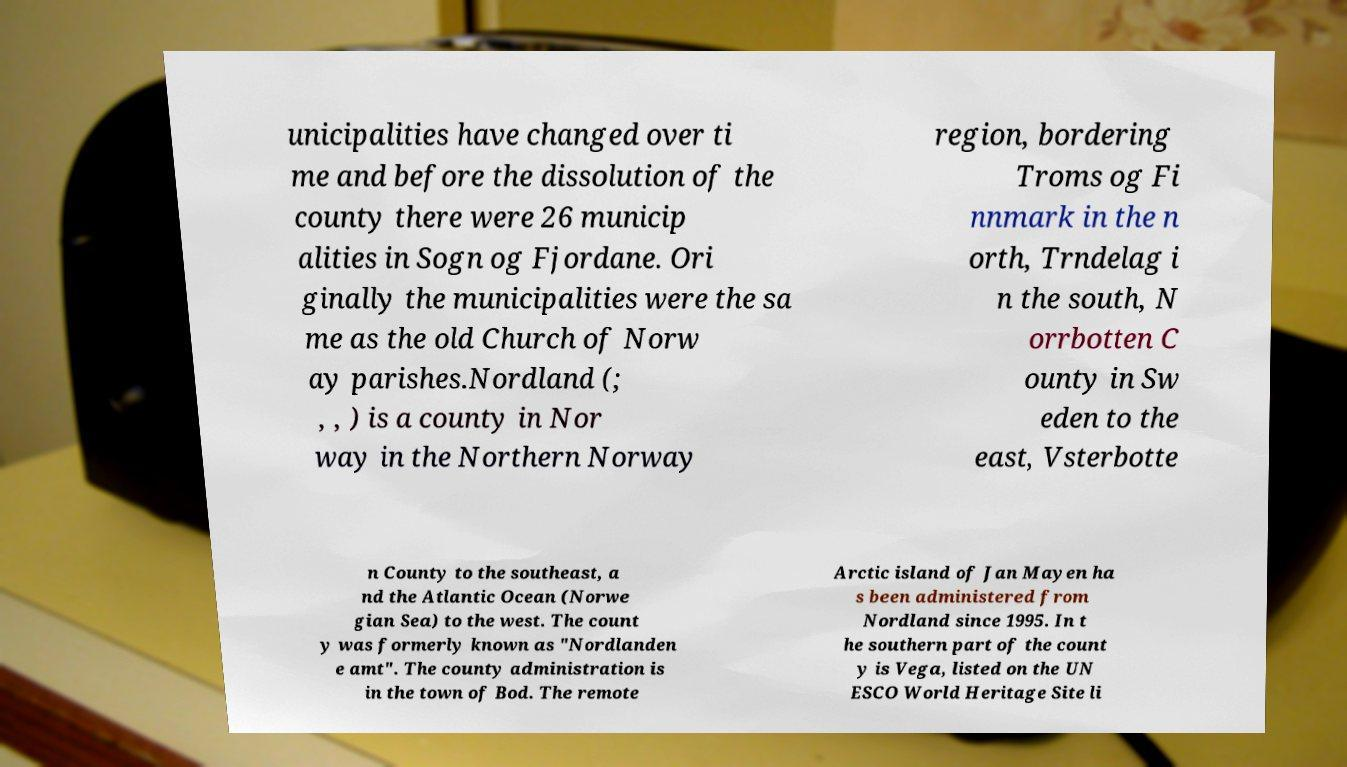Can you accurately transcribe the text from the provided image for me? unicipalities have changed over ti me and before the dissolution of the county there were 26 municip alities in Sogn og Fjordane. Ori ginally the municipalities were the sa me as the old Church of Norw ay parishes.Nordland (; , , ) is a county in Nor way in the Northern Norway region, bordering Troms og Fi nnmark in the n orth, Trndelag i n the south, N orrbotten C ounty in Sw eden to the east, Vsterbotte n County to the southeast, a nd the Atlantic Ocean (Norwe gian Sea) to the west. The count y was formerly known as "Nordlanden e amt". The county administration is in the town of Bod. The remote Arctic island of Jan Mayen ha s been administered from Nordland since 1995. In t he southern part of the count y is Vega, listed on the UN ESCO World Heritage Site li 